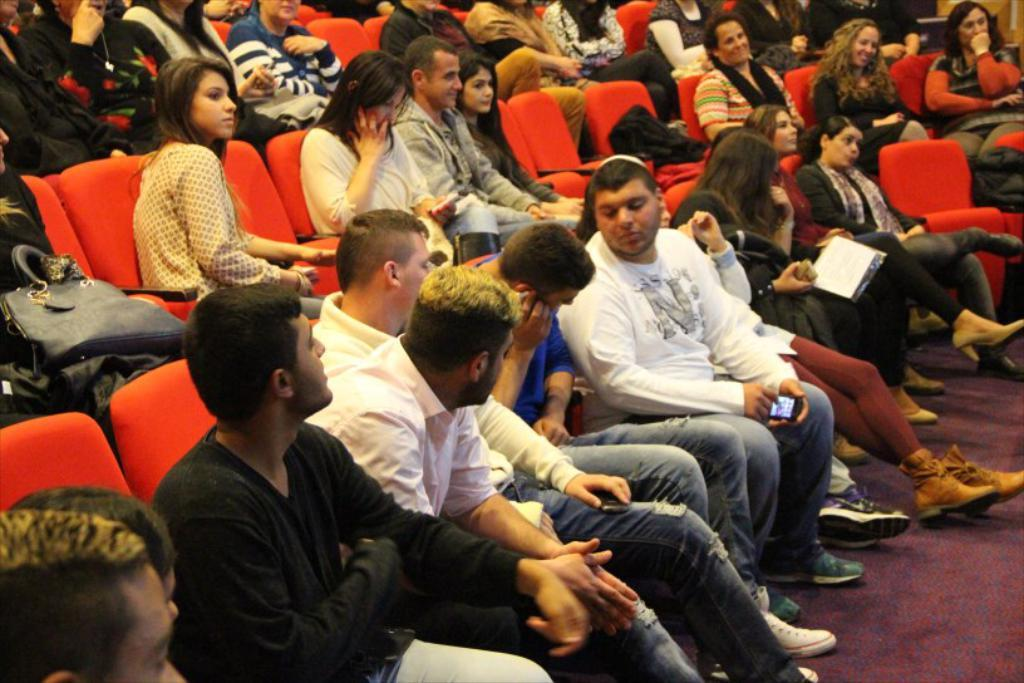What are the people in the image doing? The people in the image are sitting in chairs. Can you describe the gender of the people in the image? There are both men and women in the image. What color are the chairs in the image? The chairs in the image are red in color. What is the fifth person's desire in the image? There is no fifth person in the image, as there are only men and women sitting in the chairs. 